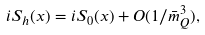Convert formula to latex. <formula><loc_0><loc_0><loc_500><loc_500>i S _ { h } ( x ) = i S _ { 0 } ( x ) + O ( 1 / \bar { m } _ { Q } ^ { 3 } ) ,</formula> 